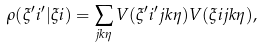Convert formula to latex. <formula><loc_0><loc_0><loc_500><loc_500>\rho ( \xi ^ { \prime } i ^ { \prime } | \xi i ) = \sum _ { j k \eta } V ( \xi ^ { \prime } i ^ { \prime } j k \eta ) V ( \xi i j k \eta ) ,</formula> 